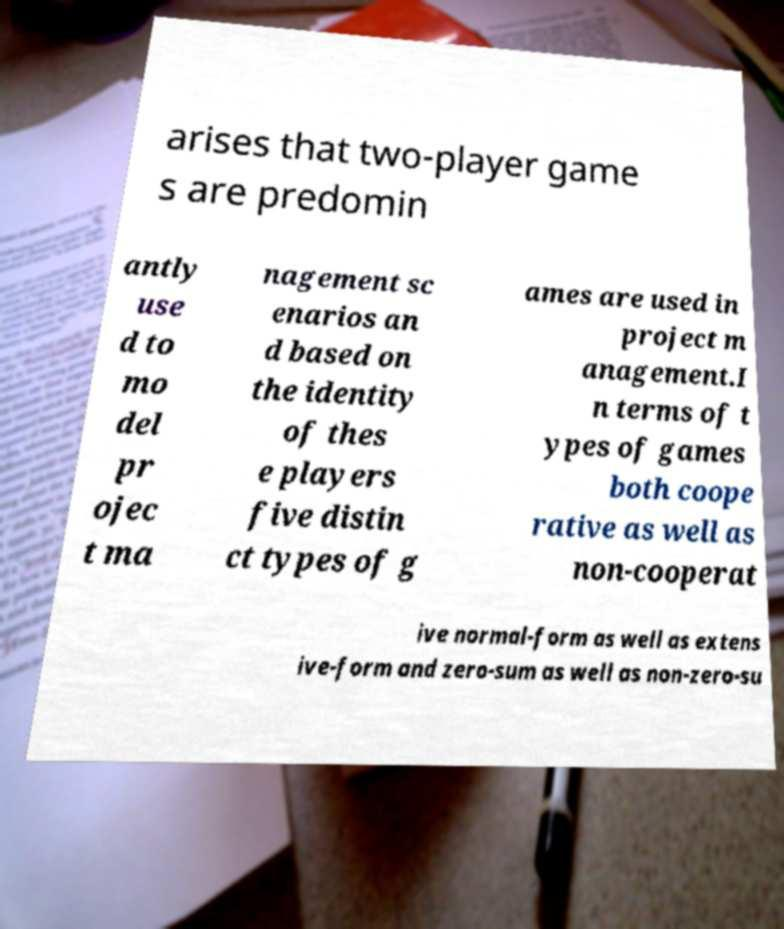Could you assist in decoding the text presented in this image and type it out clearly? arises that two-player game s are predomin antly use d to mo del pr ojec t ma nagement sc enarios an d based on the identity of thes e players five distin ct types of g ames are used in project m anagement.I n terms of t ypes of games both coope rative as well as non-cooperat ive normal-form as well as extens ive-form and zero-sum as well as non-zero-su 